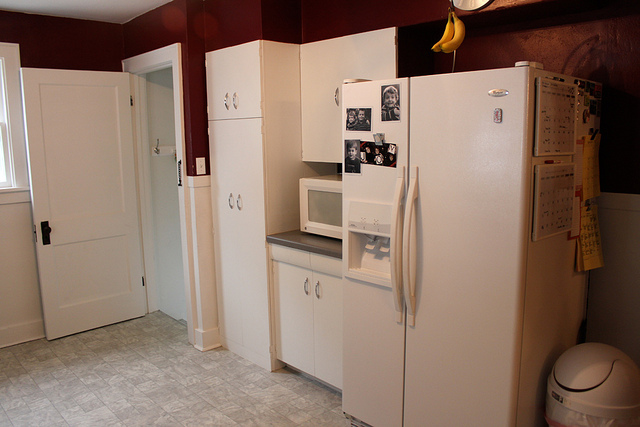Describe the color scheme of the kitchen. The kitchen's color scheme includes white appliances and cabinetry, which contrast with the deep red or maroon color of the walls. The flooring is a light, neutral color that complements the overall palette. 